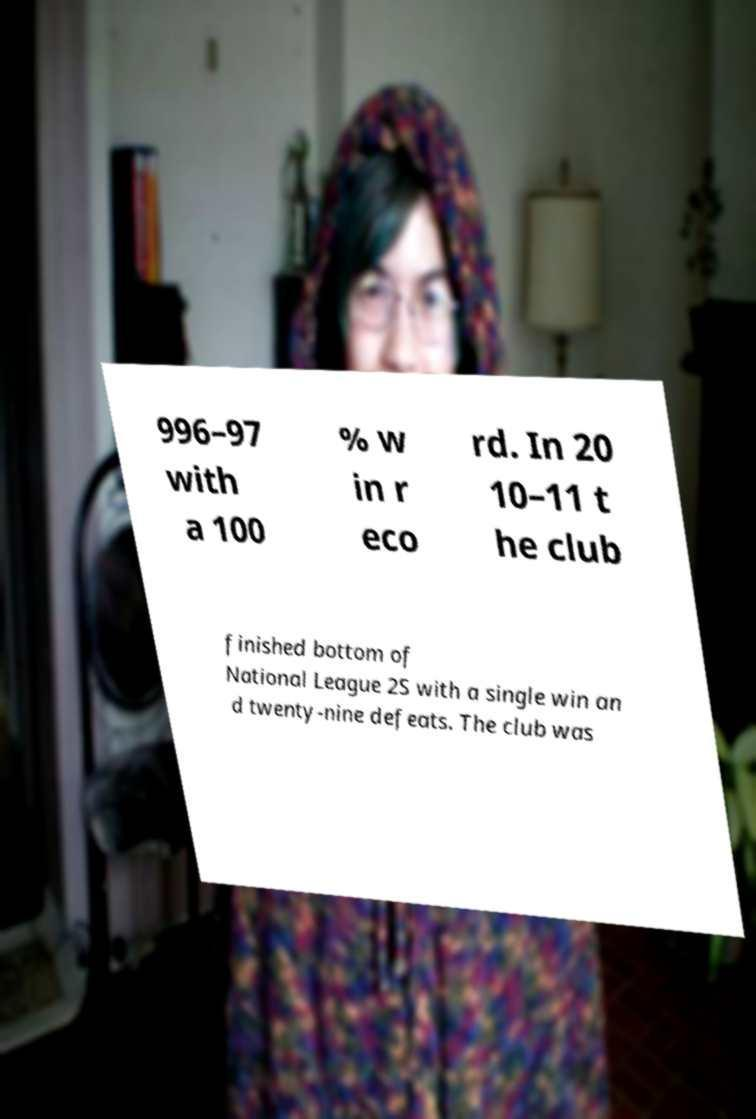Please identify and transcribe the text found in this image. 996–97 with a 100 % w in r eco rd. In 20 10–11 t he club finished bottom of National League 2S with a single win an d twenty-nine defeats. The club was 